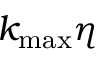Convert formula to latex. <formula><loc_0><loc_0><loc_500><loc_500>k _ { \max } \eta</formula> 